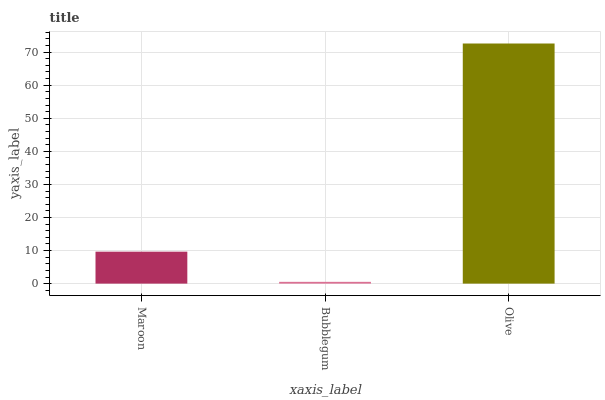Is Olive the minimum?
Answer yes or no. No. Is Bubblegum the maximum?
Answer yes or no. No. Is Olive greater than Bubblegum?
Answer yes or no. Yes. Is Bubblegum less than Olive?
Answer yes or no. Yes. Is Bubblegum greater than Olive?
Answer yes or no. No. Is Olive less than Bubblegum?
Answer yes or no. No. Is Maroon the high median?
Answer yes or no. Yes. Is Maroon the low median?
Answer yes or no. Yes. Is Olive the high median?
Answer yes or no. No. Is Bubblegum the low median?
Answer yes or no. No. 